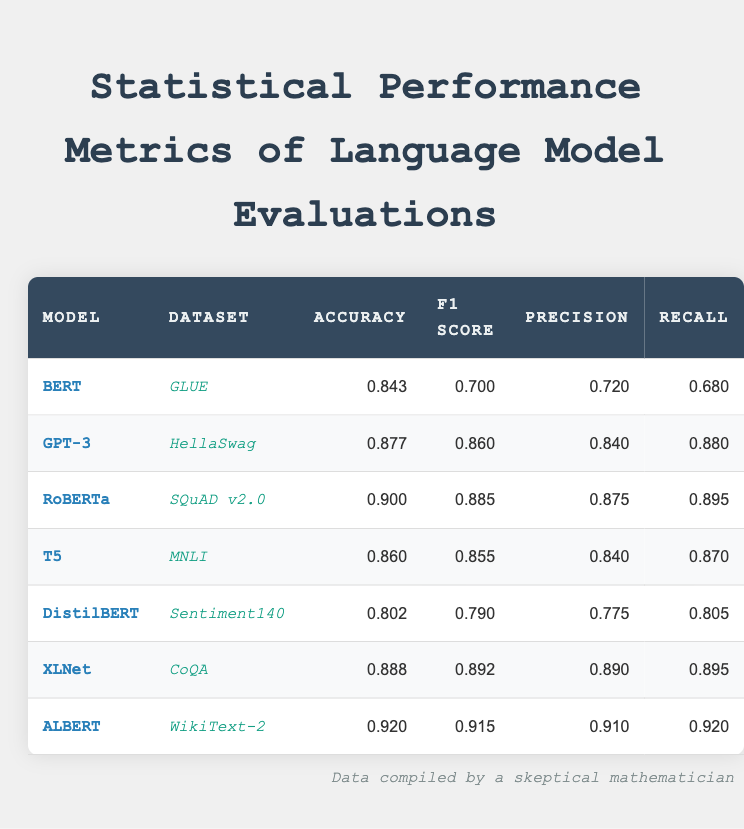What is the accuracy of the ALBERT model on the WikiText-2 dataset? The accuracy of the ALBERT model is listed in the table under the "Accuracy" column for the WikiText-2 dataset. It shows the value of 0.920.
Answer: 0.920 Which model has the highest F1 score in the table? By examining the F1 score column, the highest value is 0.915, which belongs to the ALBERT model on the WikiText-2 dataset.
Answer: ALBERT Is the precision of GPT-3 greater than 0.8? The precision value for GPT-3, as noted in the table, is 0.840. Since 0.840 is greater than 0.8, the statement is true.
Answer: Yes What is the average recall across all models? To find the average recall, sum the recall values of all models (0.680 + 0.880 + 0.895 + 0.870 + 0.805 + 0.895 + 0.920 = 5.145) and divide by the total number of models (7). The average recall is therefore 5.145 / 7 = approximately 0.735.
Answer: 0.735 Which model has the lowest accuracy, and what is its value? The model with the lowest accuracy can be identified by comparing all accuracy values in the table. The lowest accuracy is found for DistilBERT at 0.802.
Answer: DistilBERT, 0.802 Is the recall of the RoBERTa model higher than its precision? The recall for RoBERTa is 0.895 and precision is 0.875. Since 0.895 is greater than 0.875, the statement is true.
Answer: Yes What is the difference in accuracy between BERT and T5 models? The accuracy for BERT is 0.843 and for T5 is 0.860. The difference is calculated as 0.860 - 0.843 = 0.017.
Answer: 0.017 Which model achieved an accuracy of 0.900, and what is its corresponding dataset? By scanning the accuracy column for the value of 0.900, it is found for the RoBERTa model. The dataset associated with it is SQuAD v2.0.
Answer: RoBERTa, SQuAD v2.0 